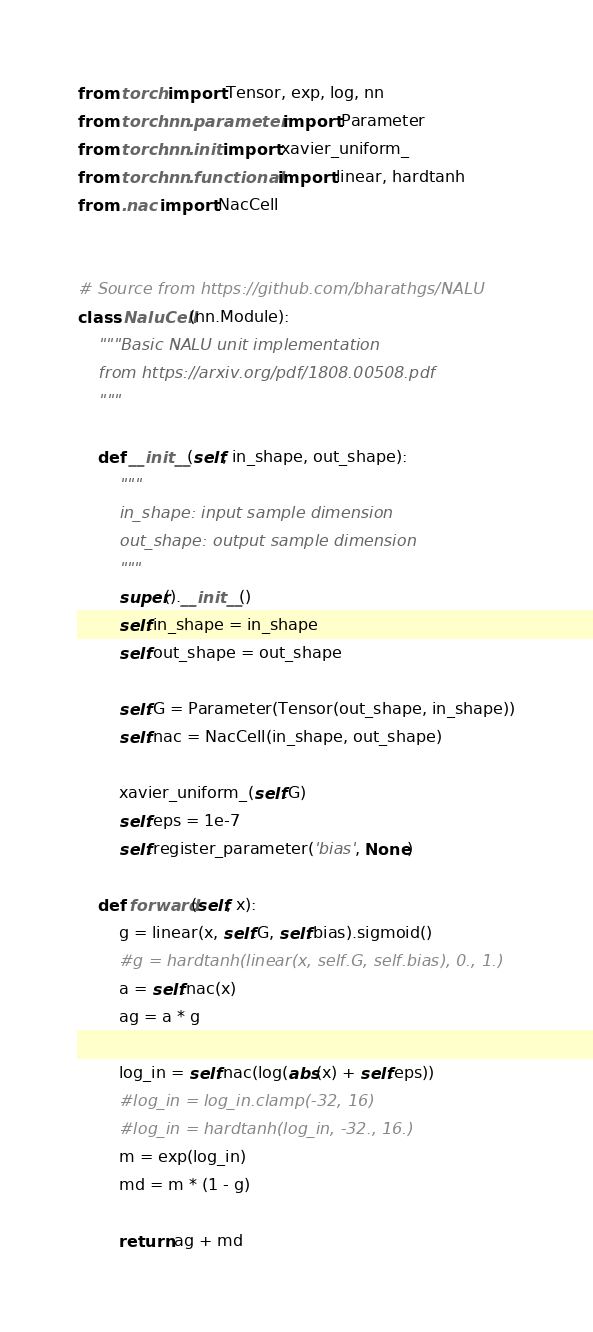Convert code to text. <code><loc_0><loc_0><loc_500><loc_500><_Python_>from torch import Tensor, exp, log, nn
from torch.nn.parameter import Parameter
from torch.nn.init import xavier_uniform_
from torch.nn.functional import linear, hardtanh
from .nac import NacCell


# Source from https://github.com/bharathgs/NALU
class NaluCell(nn.Module):
    """Basic NALU unit implementation
    from https://arxiv.org/pdf/1808.00508.pdf
    """

    def __init__(self, in_shape, out_shape):
        """
        in_shape: input sample dimension
        out_shape: output sample dimension
        """
        super().__init__()
        self.in_shape = in_shape
        self.out_shape = out_shape

        self.G = Parameter(Tensor(out_shape, in_shape))
        self.nac = NacCell(in_shape, out_shape)

        xavier_uniform_(self.G)
        self.eps = 1e-7
        self.register_parameter('bias', None)

    def forward(self, x):
        g = linear(x, self.G, self.bias).sigmoid()
        #g = hardtanh(linear(x, self.G, self.bias), 0., 1.)
        a = self.nac(x)
        ag = a * g

        log_in = self.nac(log(abs(x) + self.eps))
        #log_in = log_in.clamp(-32, 16)
        #log_in = hardtanh(log_in, -32., 16.)
        m = exp(log_in)
        md = m * (1 - g)

        return ag + md
</code> 